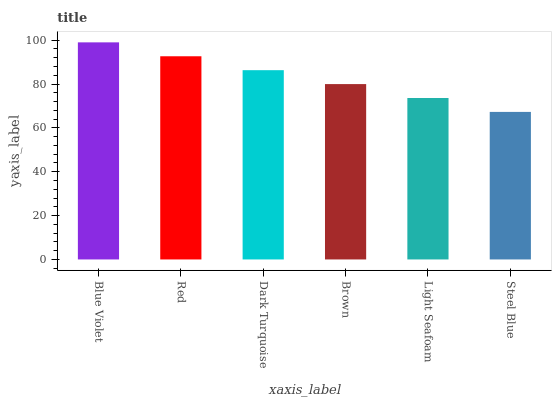Is Steel Blue the minimum?
Answer yes or no. Yes. Is Blue Violet the maximum?
Answer yes or no. Yes. Is Red the minimum?
Answer yes or no. No. Is Red the maximum?
Answer yes or no. No. Is Blue Violet greater than Red?
Answer yes or no. Yes. Is Red less than Blue Violet?
Answer yes or no. Yes. Is Red greater than Blue Violet?
Answer yes or no. No. Is Blue Violet less than Red?
Answer yes or no. No. Is Dark Turquoise the high median?
Answer yes or no. Yes. Is Brown the low median?
Answer yes or no. Yes. Is Blue Violet the high median?
Answer yes or no. No. Is Dark Turquoise the low median?
Answer yes or no. No. 